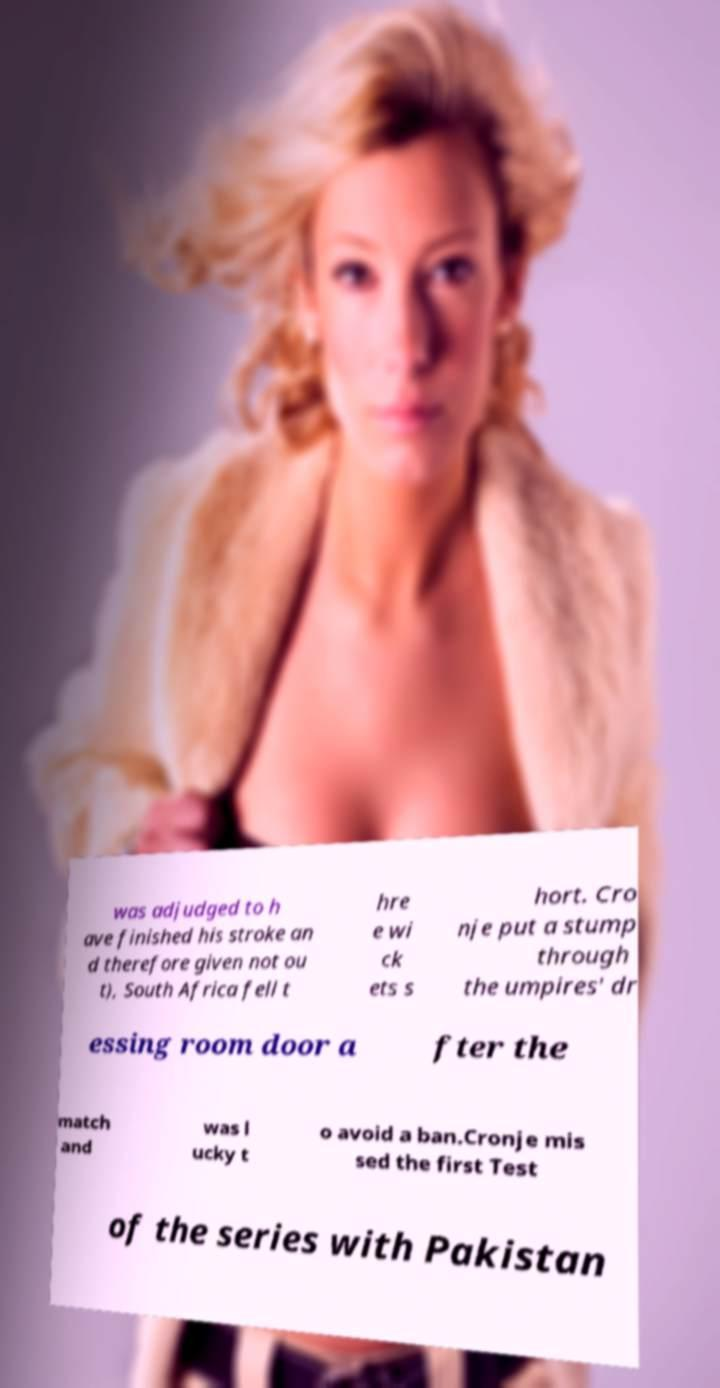I need the written content from this picture converted into text. Can you do that? was adjudged to h ave finished his stroke an d therefore given not ou t), South Africa fell t hre e wi ck ets s hort. Cro nje put a stump through the umpires' dr essing room door a fter the match and was l ucky t o avoid a ban.Cronje mis sed the first Test of the series with Pakistan 